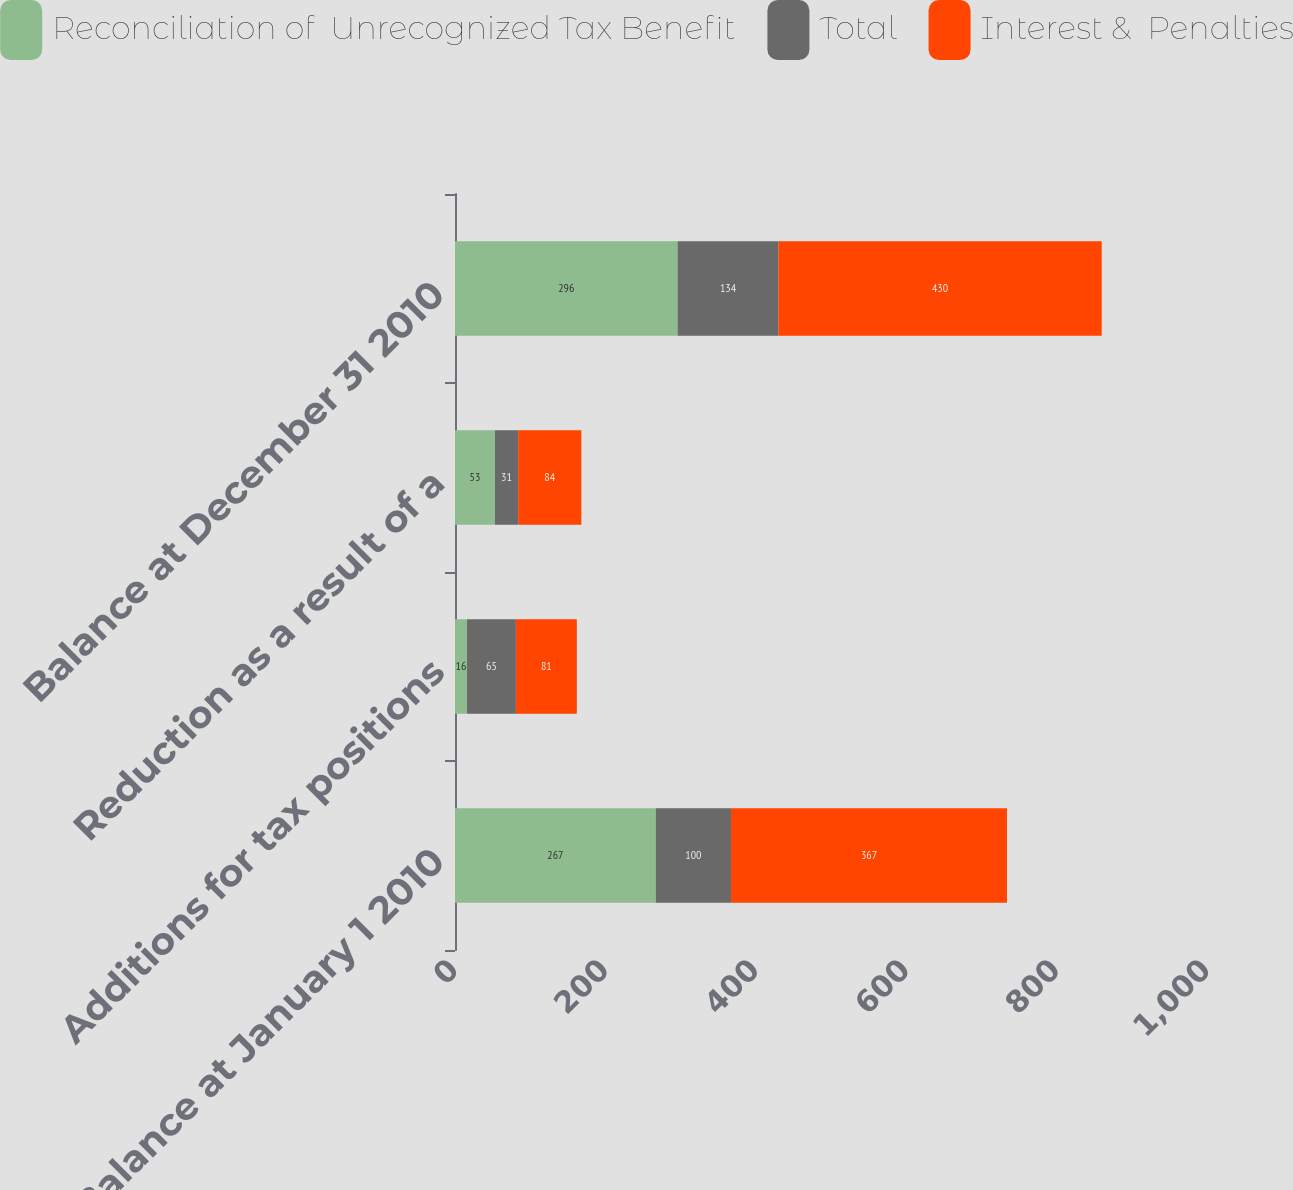Convert chart to OTSL. <chart><loc_0><loc_0><loc_500><loc_500><stacked_bar_chart><ecel><fcel>Balance at January 1 2010<fcel>Additions for tax positions<fcel>Reduction as a result of a<fcel>Balance at December 31 2010<nl><fcel>Reconciliation of  Unrecognized Tax Benefit<fcel>267<fcel>16<fcel>53<fcel>296<nl><fcel>Total<fcel>100<fcel>65<fcel>31<fcel>134<nl><fcel>Interest &  Penalties<fcel>367<fcel>81<fcel>84<fcel>430<nl></chart> 